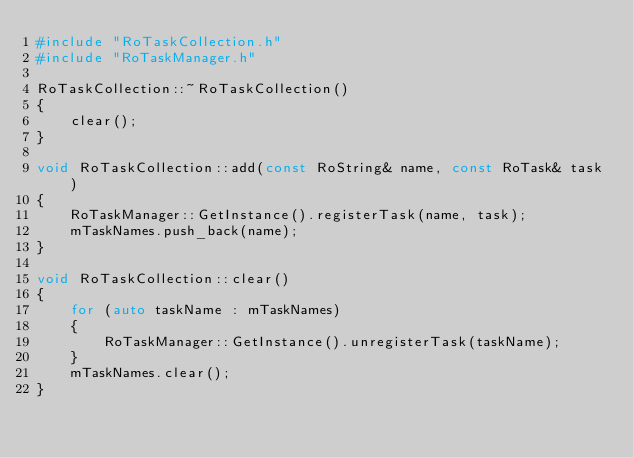Convert code to text. <code><loc_0><loc_0><loc_500><loc_500><_C++_>#include "RoTaskCollection.h"
#include "RoTaskManager.h"

RoTaskCollection::~RoTaskCollection()
{
    clear();
}

void RoTaskCollection::add(const RoString& name, const RoTask& task)
{
    RoTaskManager::GetInstance().registerTask(name, task);
    mTaskNames.push_back(name);
}

void RoTaskCollection::clear()
{
    for (auto taskName : mTaskNames)
    {
        RoTaskManager::GetInstance().unregisterTask(taskName);
    }
    mTaskNames.clear();
}
</code> 